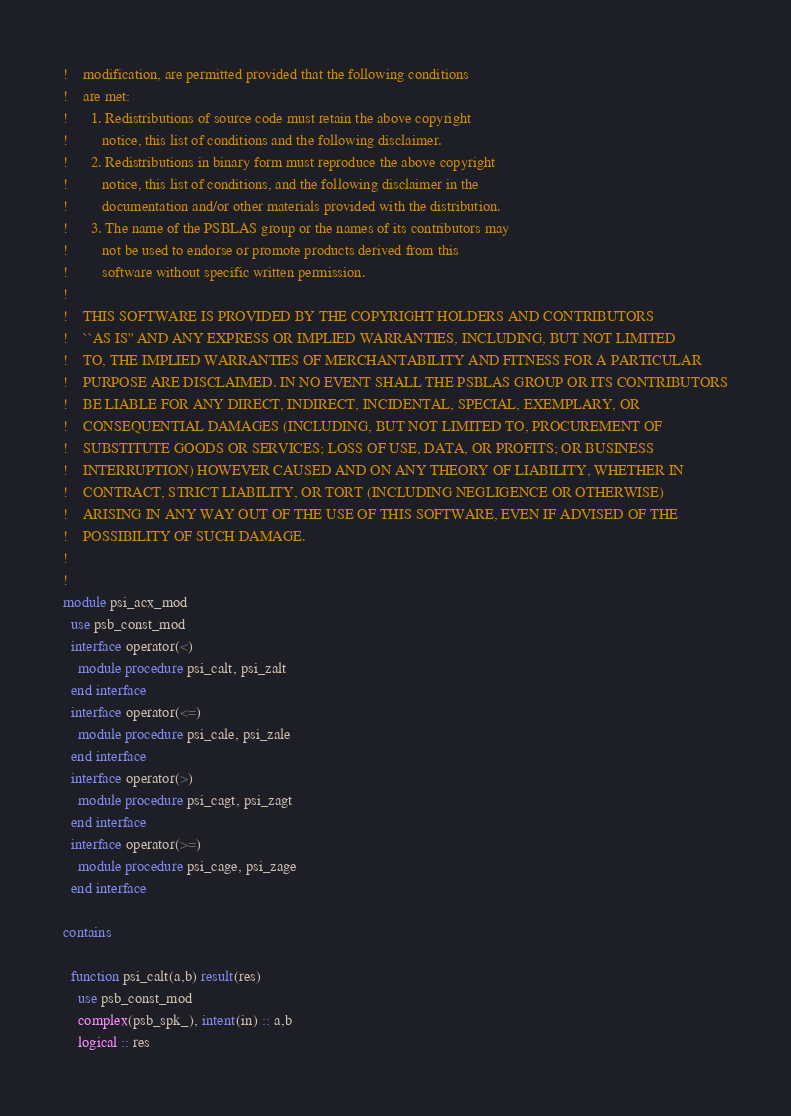Convert code to text. <code><loc_0><loc_0><loc_500><loc_500><_FORTRAN_>!    modification, are permitted provided that the following conditions
!    are met:
!      1. Redistributions of source code must retain the above copyright
!         notice, this list of conditions and the following disclaimer.
!      2. Redistributions in binary form must reproduce the above copyright
!         notice, this list of conditions, and the following disclaimer in the
!         documentation and/or other materials provided with the distribution.
!      3. The name of the PSBLAS group or the names of its contributors may
!         not be used to endorse or promote products derived from this
!         software without specific written permission.
!   
!    THIS SOFTWARE IS PROVIDED BY THE COPYRIGHT HOLDERS AND CONTRIBUTORS
!    ``AS IS'' AND ANY EXPRESS OR IMPLIED WARRANTIES, INCLUDING, BUT NOT LIMITED
!    TO, THE IMPLIED WARRANTIES OF MERCHANTABILITY AND FITNESS FOR A PARTICULAR
!    PURPOSE ARE DISCLAIMED. IN NO EVENT SHALL THE PSBLAS GROUP OR ITS CONTRIBUTORS
!    BE LIABLE FOR ANY DIRECT, INDIRECT, INCIDENTAL, SPECIAL, EXEMPLARY, OR
!    CONSEQUENTIAL DAMAGES (INCLUDING, BUT NOT LIMITED TO, PROCUREMENT OF
!    SUBSTITUTE GOODS OR SERVICES; LOSS OF USE, DATA, OR PROFITS; OR BUSINESS
!    INTERRUPTION) HOWEVER CAUSED AND ON ANY THEORY OF LIABILITY, WHETHER IN
!    CONTRACT, STRICT LIABILITY, OR TORT (INCLUDING NEGLIGENCE OR OTHERWISE)
!    ARISING IN ANY WAY OUT OF THE USE OF THIS SOFTWARE, EVEN IF ADVISED OF THE
!    POSSIBILITY OF SUCH DAMAGE.
!   
!    
module psi_acx_mod
  use psb_const_mod
  interface operator(<)
    module procedure psi_calt, psi_zalt
  end interface
  interface operator(<=)
    module procedure psi_cale, psi_zale
  end interface
  interface operator(>)
    module procedure psi_cagt, psi_zagt
  end interface
  interface operator(>=)
    module procedure psi_cage, psi_zage
  end interface

contains

  function psi_calt(a,b) result(res)
    use psb_const_mod
    complex(psb_spk_), intent(in) :: a,b
    logical :: res
</code> 